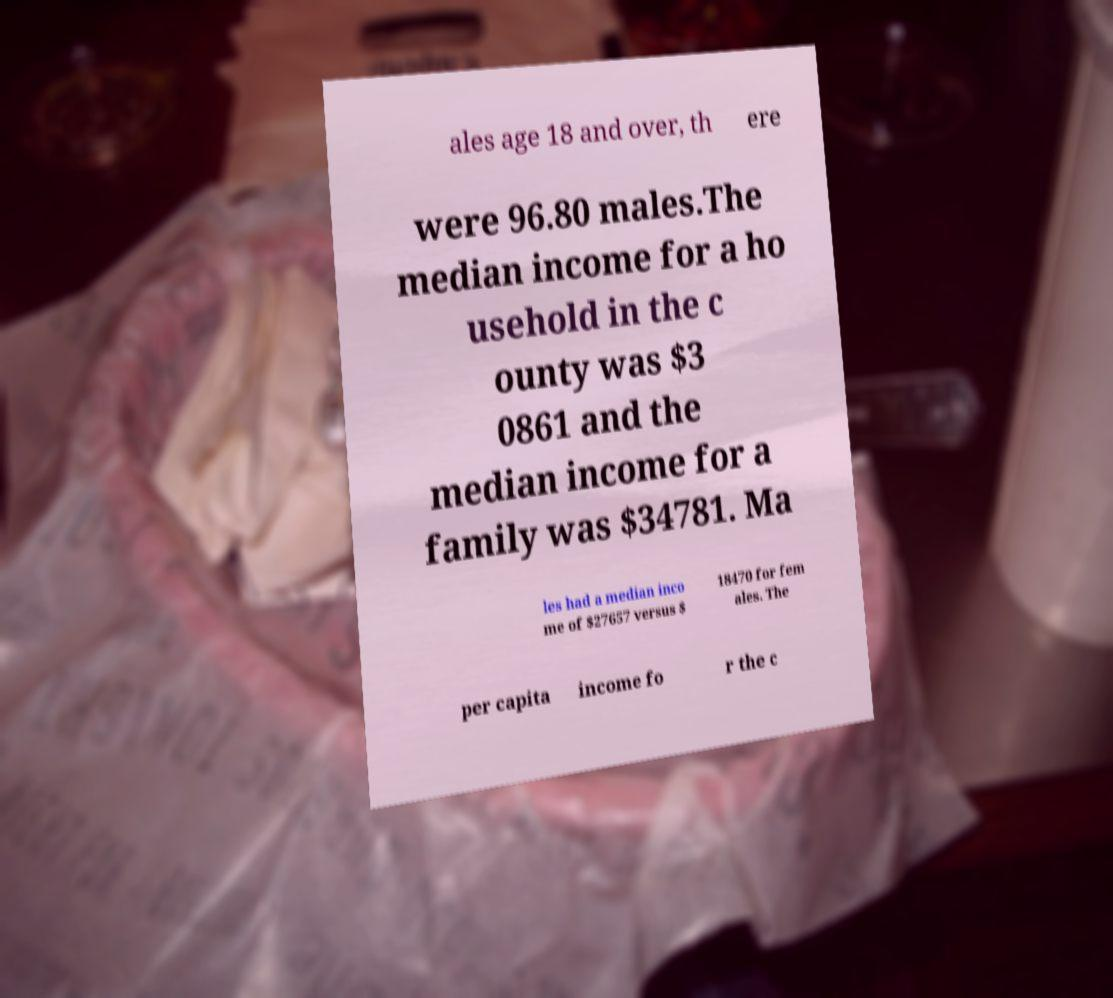Can you accurately transcribe the text from the provided image for me? ales age 18 and over, th ere were 96.80 males.The median income for a ho usehold in the c ounty was $3 0861 and the median income for a family was $34781. Ma les had a median inco me of $27657 versus $ 18470 for fem ales. The per capita income fo r the c 